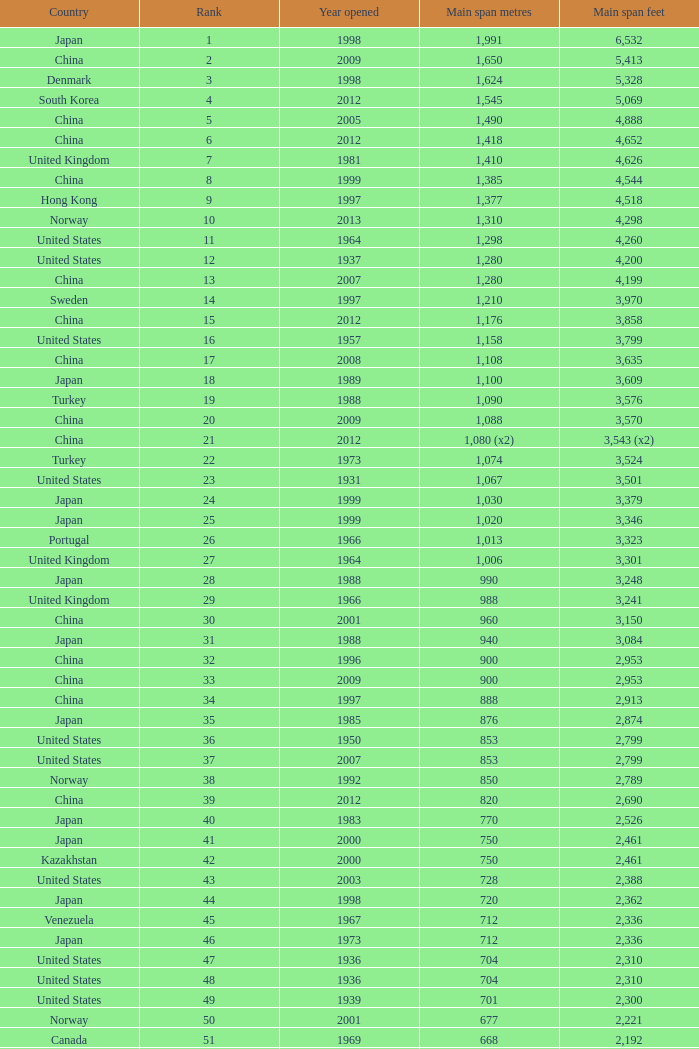What is the highest rank from the year greater than 2010 with 430 main span metres? 94.0. 